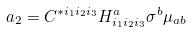<formula> <loc_0><loc_0><loc_500><loc_500>a _ { 2 } = C ^ { * i _ { 1 } i _ { 2 } i _ { 3 } } H ^ { a } _ { i _ { 1 } i _ { 2 } i _ { 3 } } \sigma ^ { b } \mu _ { a b }</formula> 